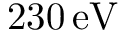Convert formula to latex. <formula><loc_0><loc_0><loc_500><loc_500>2 3 0 \, { e V }</formula> 